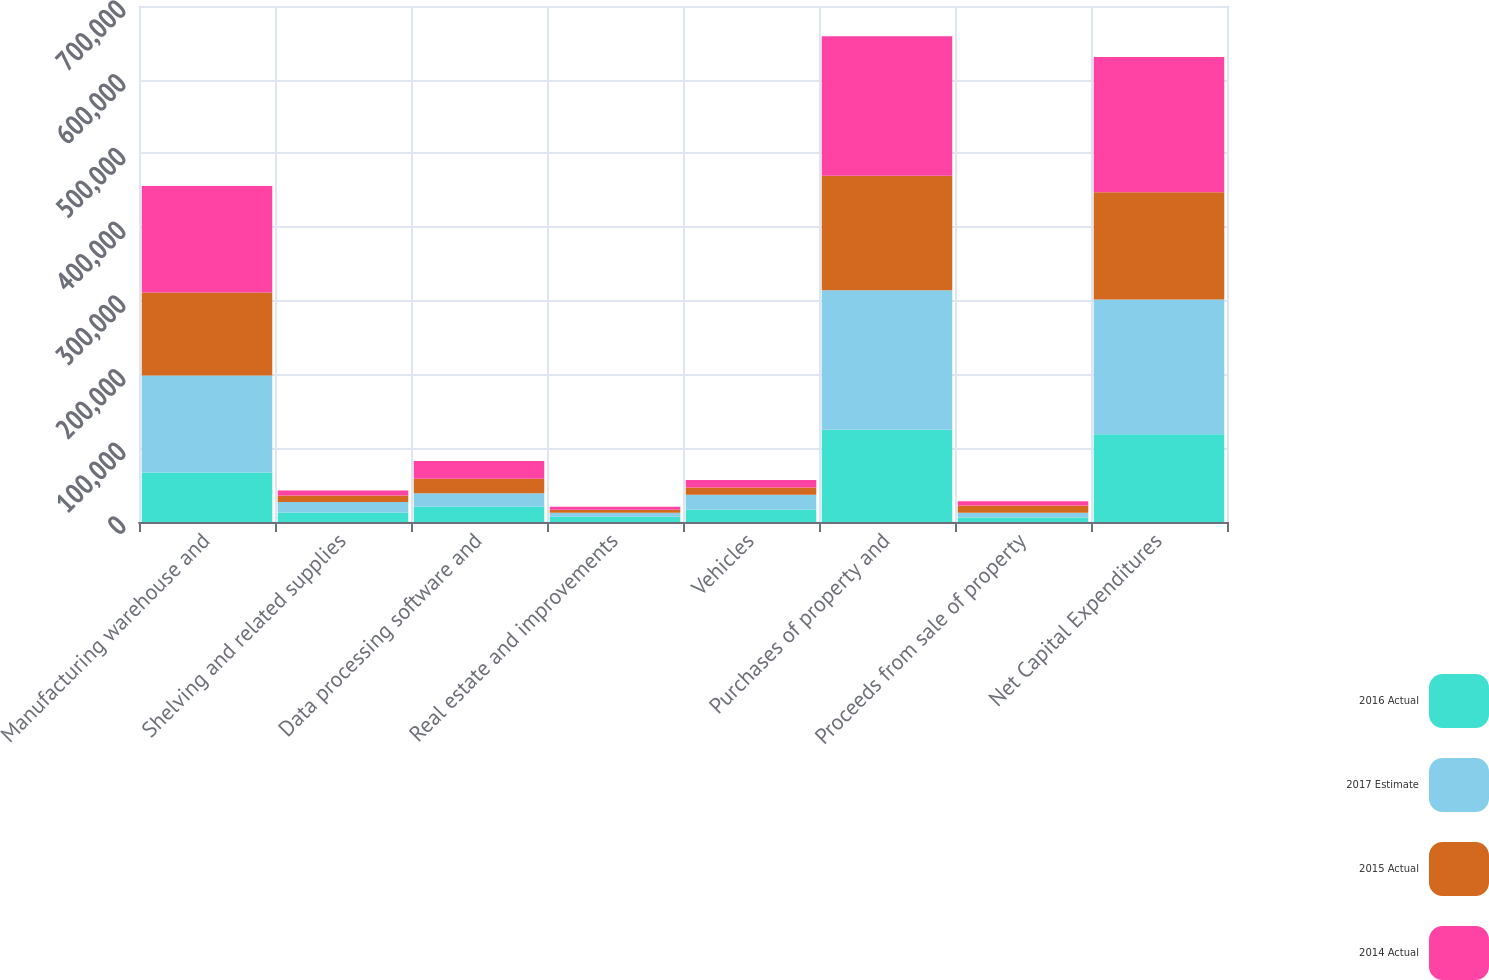Convert chart. <chart><loc_0><loc_0><loc_500><loc_500><stacked_bar_chart><ecel><fcel>Manufacturing warehouse and<fcel>Shelving and related supplies<fcel>Data processing software and<fcel>Real estate and improvements<fcel>Vehicles<fcel>Purchases of property and<fcel>Proceeds from sale of property<fcel>Net Capital Expenditures<nl><fcel>2016 Actual<fcel>67000<fcel>13000<fcel>21000<fcel>7000<fcel>17000<fcel>125000<fcel>6000<fcel>119000<nl><fcel>2017 Estimate<fcel>131793<fcel>14079<fcel>18015<fcel>5467<fcel>20097<fcel>189451<fcel>6505<fcel>182946<nl><fcel>2015 Actual<fcel>112460<fcel>8958<fcel>19653<fcel>4247<fcel>9850<fcel>155168<fcel>9941<fcel>145227<nl><fcel>2014 Actual<fcel>144649<fcel>6712<fcel>23978<fcel>4091<fcel>10044<fcel>189474<fcel>5819<fcel>183655<nl></chart> 